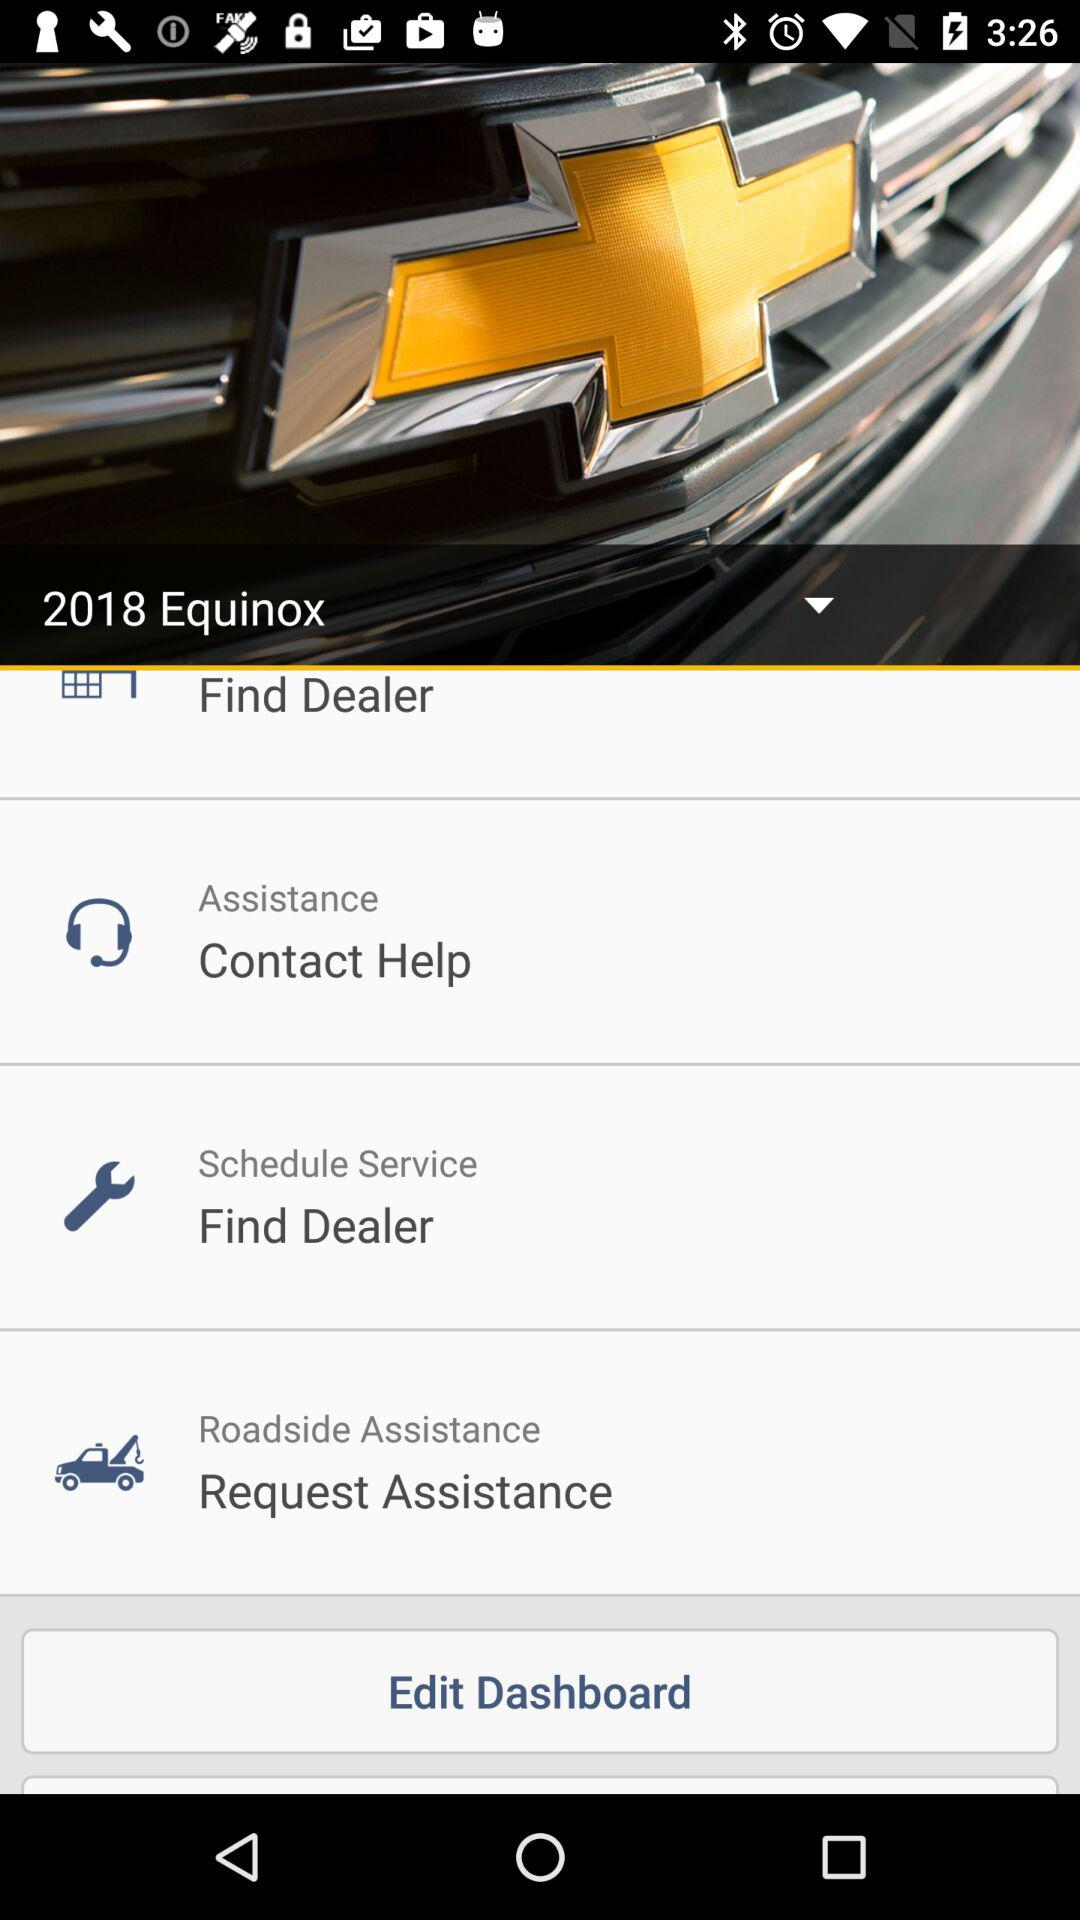What is the car model? The car model is the "2018 Equinox". 